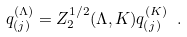<formula> <loc_0><loc_0><loc_500><loc_500>q _ { ( j ) } ^ { ( \Lambda ) } = Z _ { 2 } ^ { 1 / 2 } ( \Lambda , K ) q _ { ( j ) } ^ { ( K ) } \ .</formula> 